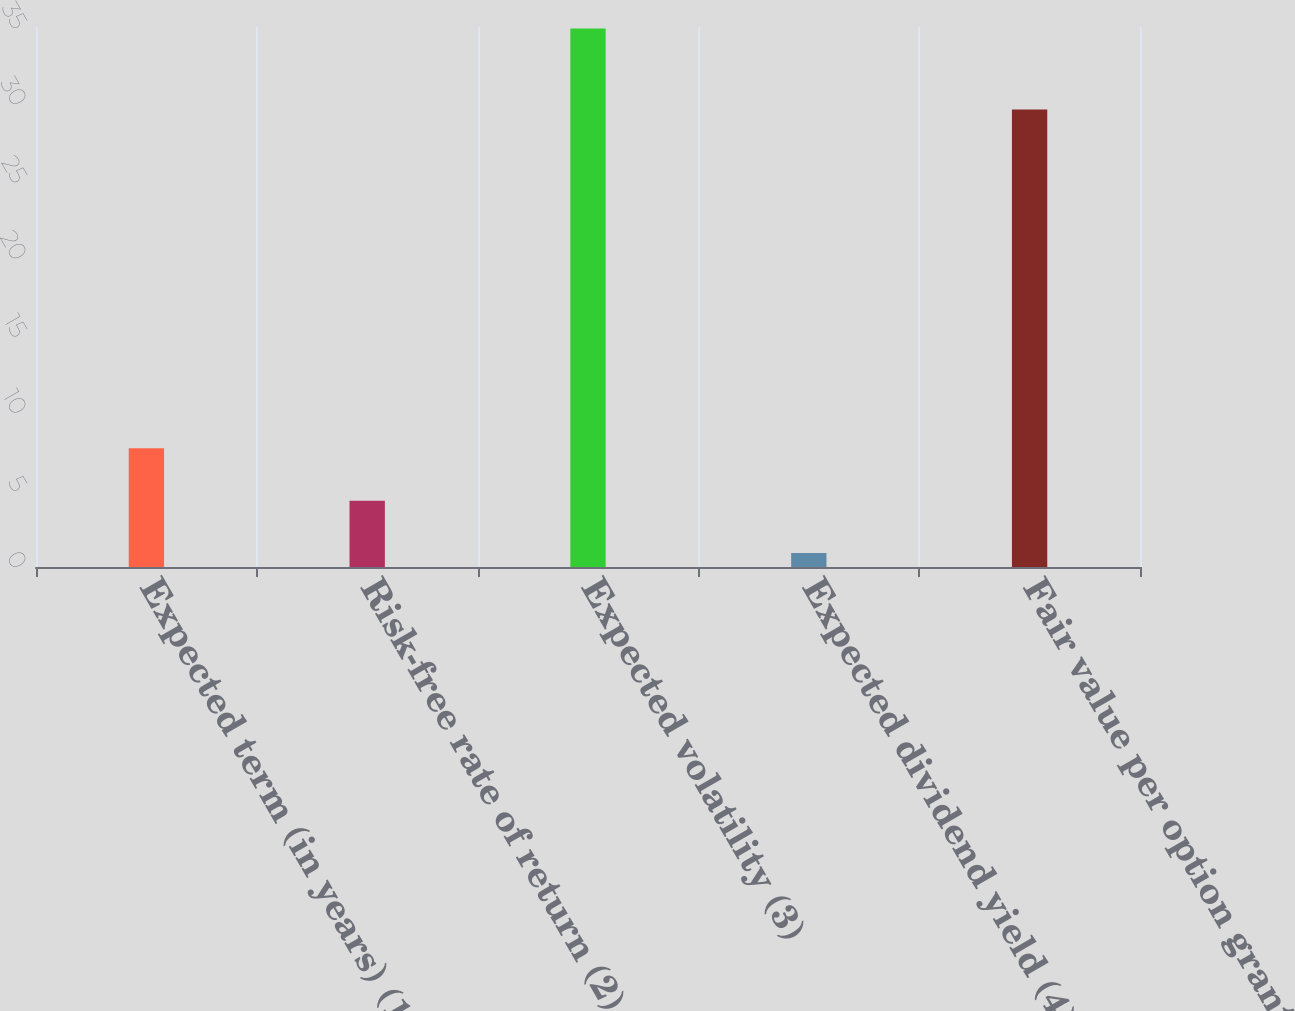<chart> <loc_0><loc_0><loc_500><loc_500><bar_chart><fcel>Expected term (in years) (1)<fcel>Risk-free rate of return (2)<fcel>Expected volatility (3)<fcel>Expected dividend yield (4)<fcel>Fair value per option granted<nl><fcel>7.7<fcel>4.3<fcel>34.9<fcel>0.9<fcel>29.65<nl></chart> 